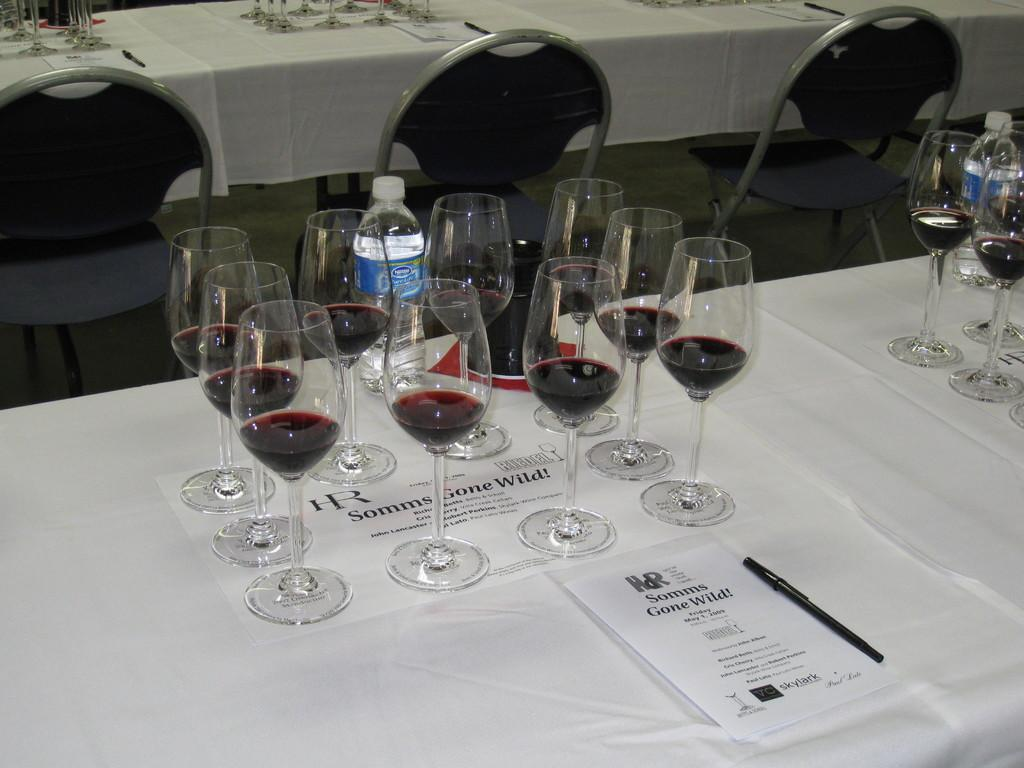What type of furniture can be seen in the image? There are tables in the image. What is placed on the tables? Wine glasses, bottles, papers, and pens are visible on the tables. Are there any seating options in the image? Yes, chairs are in the image. What hobbies does the grandmother in the image enjoy? There is no grandmother present in the image, so we cannot determine her hobbies. 